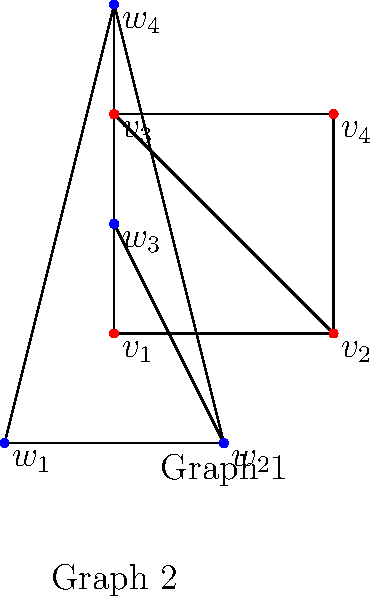Consider the two graphs shown above. At first glance, they appear similar, but are they isomorphic? Provide a rigorous proof or counterexample to support your answer. To determine if the two graphs are isomorphic, we need to check if there exists a bijective function between their vertex sets that preserves adjacency. Let's approach this step-by-step:

1) Both graphs have 4 vertices and 5 edges, which is a necessary (but not sufficient) condition for isomorphism.

2) Let's examine the degree of each vertex:
   Graph 1: $\deg(v_1) = 2, \deg(v_2) = 3, \deg(v_3) = 3, \deg(v_4) = 2$
   Graph 2: $\deg(w_1) = 2, \deg(w_2) = 3, \deg(w_3) = 2, \deg(w_4) = 3$

3) The degree sequences match, which is another necessary (but still not sufficient) condition for isomorphism.

4) Now, let's try to find a bijective mapping that preserves adjacency:
   $v_1 \rightarrow w_1$
   $v_2 \rightarrow w_2$
   $v_3 \rightarrow w_4$
   $v_4 \rightarrow w_3$

5) Let's check if this mapping preserves adjacency:
   - $v_1$ is adjacent to $v_2$ and $v_3$; $w_1$ is adjacent to $w_2$ and $w_4$. ✓
   - $v_2$ is adjacent to $v_1$, $v_3$, and $v_4$; $w_2$ is adjacent to $w_1$, $w_3$, and $w_4$. ✓
   - $v_3$ is adjacent to $v_1$, $v_2$, and $v_4$; $w_4$ is adjacent to $w_1$, $w_2$, and $w_3$. ✓
   - $v_4$ is adjacent to $v_2$ and $v_3$; $w_3$ is adjacent to $w_2$ and $w_4$. ✓

6) The mapping preserves adjacency for all vertices, and it's bijective.

Therefore, we have found an isomorphism between the two graphs, proving that they are indeed isomorphic.
Answer: Yes, the graphs are isomorphic. 